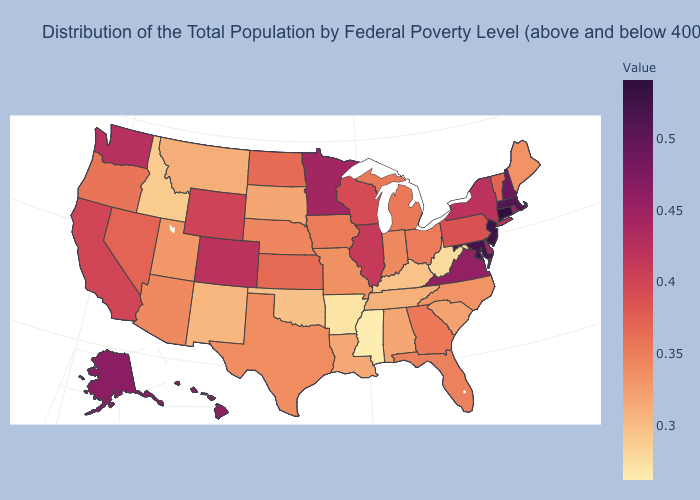Does Minnesota have the highest value in the MidWest?
Concise answer only. Yes. Does Michigan have the lowest value in the MidWest?
Answer briefly. No. Among the states that border Mississippi , does Louisiana have the lowest value?
Quick response, please. No. Does Wisconsin have a lower value than Virginia?
Write a very short answer. Yes. 